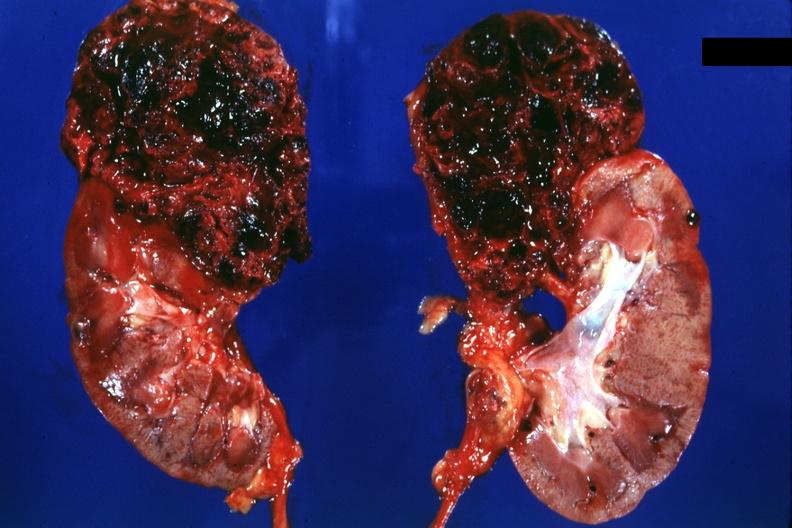how many halves does this image show of kidney with superior pole very hemorrhagic tumor?
Answer the question using a single word or phrase. Two 